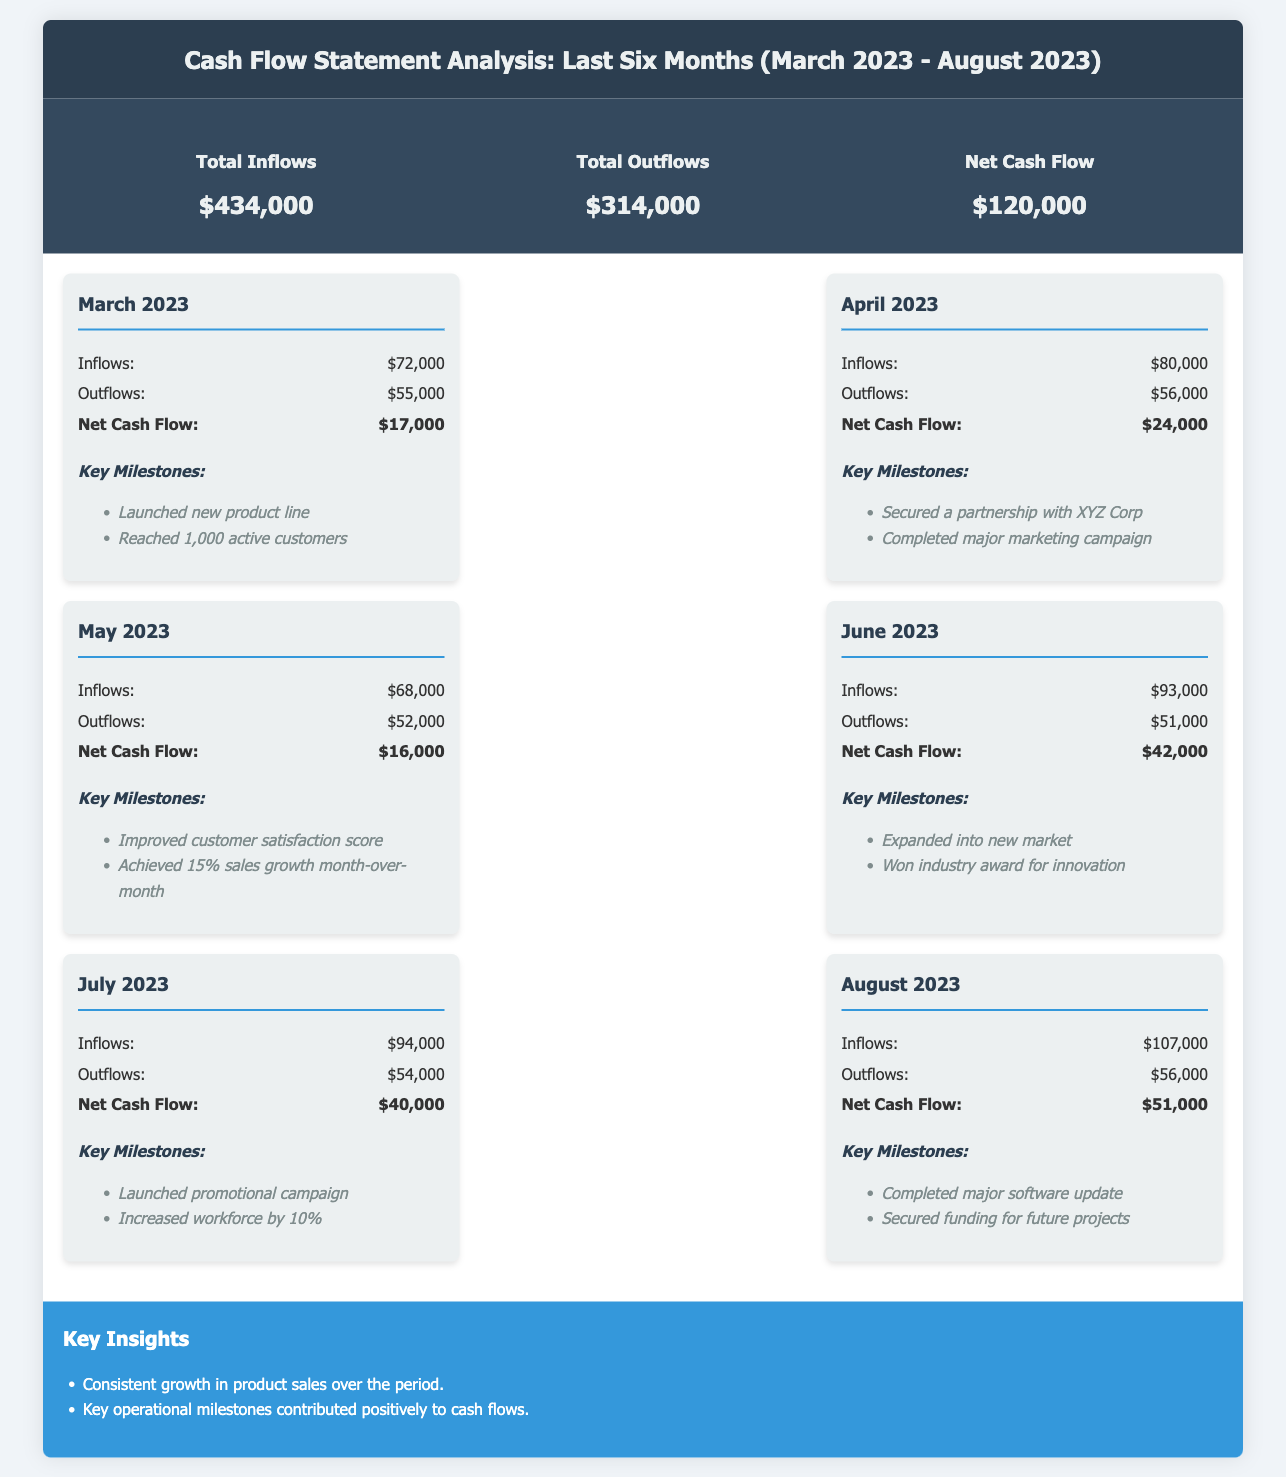What is the total inflows for the last six months? The total inflows are summarized in the document as $434,000.
Answer: $434,000 What was the net cash flow in June 2023? The net cash flow for June 2023 is listed as $42,000 in the monthly data.
Answer: $42,000 Which month had the highest inflows? By examining the monthly inflows, August 2023 had the highest inflows at $107,000.
Answer: $107,000 What key milestone was reached in March 2023? The document states that in March 2023, a new product line was launched.
Answer: Launched new product line What is the total outflows for the last six months? The total outflows are summarized in the document as $314,000.
Answer: $314,000 What was the net cash flow in April 2023? The net cash flow for April 2023 is listed as $24,000 in the monthly data.
Answer: $24,000 Which month contributed the least to net cash flow? May 2023 contributed the least to net cash flow with a total of $16,000.
Answer: $16,000 How many key milestones are listed for July 2023? The document lists two key milestones for July 2023.
Answer: 2 What was the total increase in net cash flow from March to August 2023? The net cash flow increased from $17,000 in March to $51,000 in August, resulting in a total increase of $34,000.
Answer: $34,000 